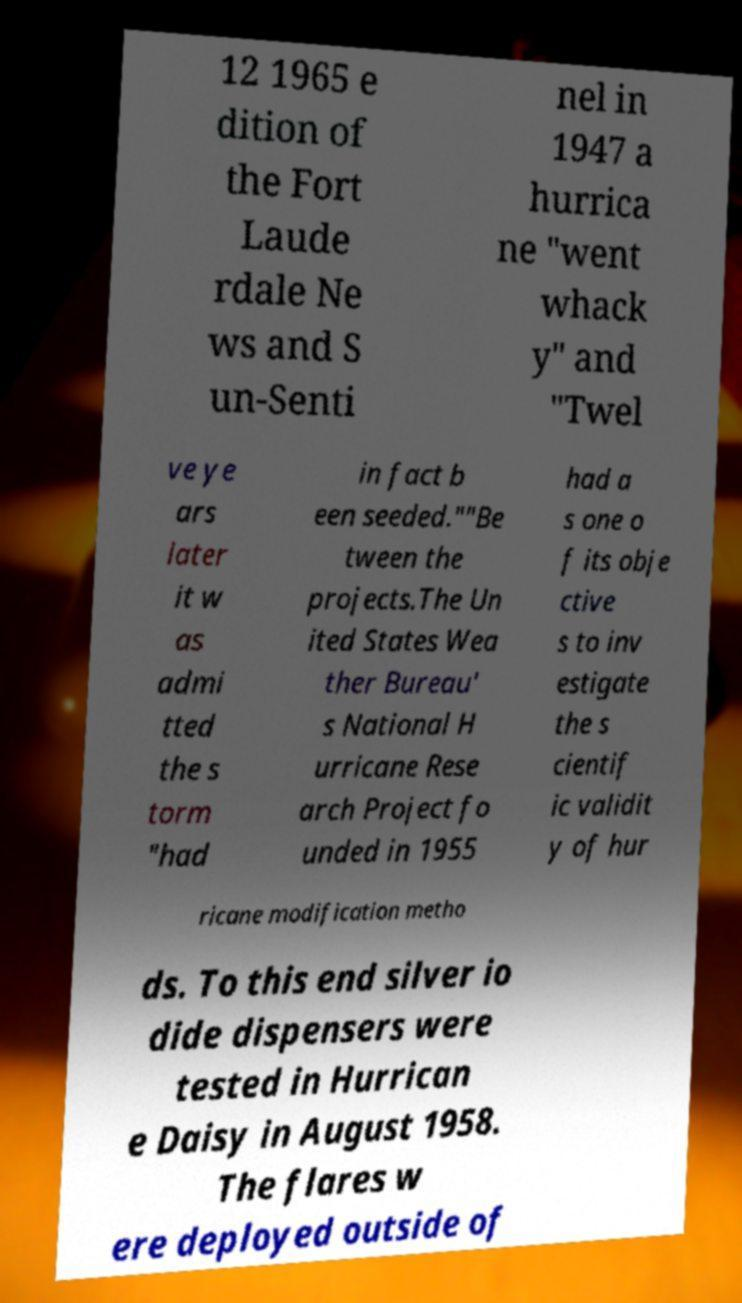Can you accurately transcribe the text from the provided image for me? 12 1965 e dition of the Fort Laude rdale Ne ws and S un-Senti nel in 1947 a hurrica ne "went whack y" and "Twel ve ye ars later it w as admi tted the s torm "had in fact b een seeded.""Be tween the projects.The Un ited States Wea ther Bureau' s National H urricane Rese arch Project fo unded in 1955 had a s one o f its obje ctive s to inv estigate the s cientif ic validit y of hur ricane modification metho ds. To this end silver io dide dispensers were tested in Hurrican e Daisy in August 1958. The flares w ere deployed outside of 